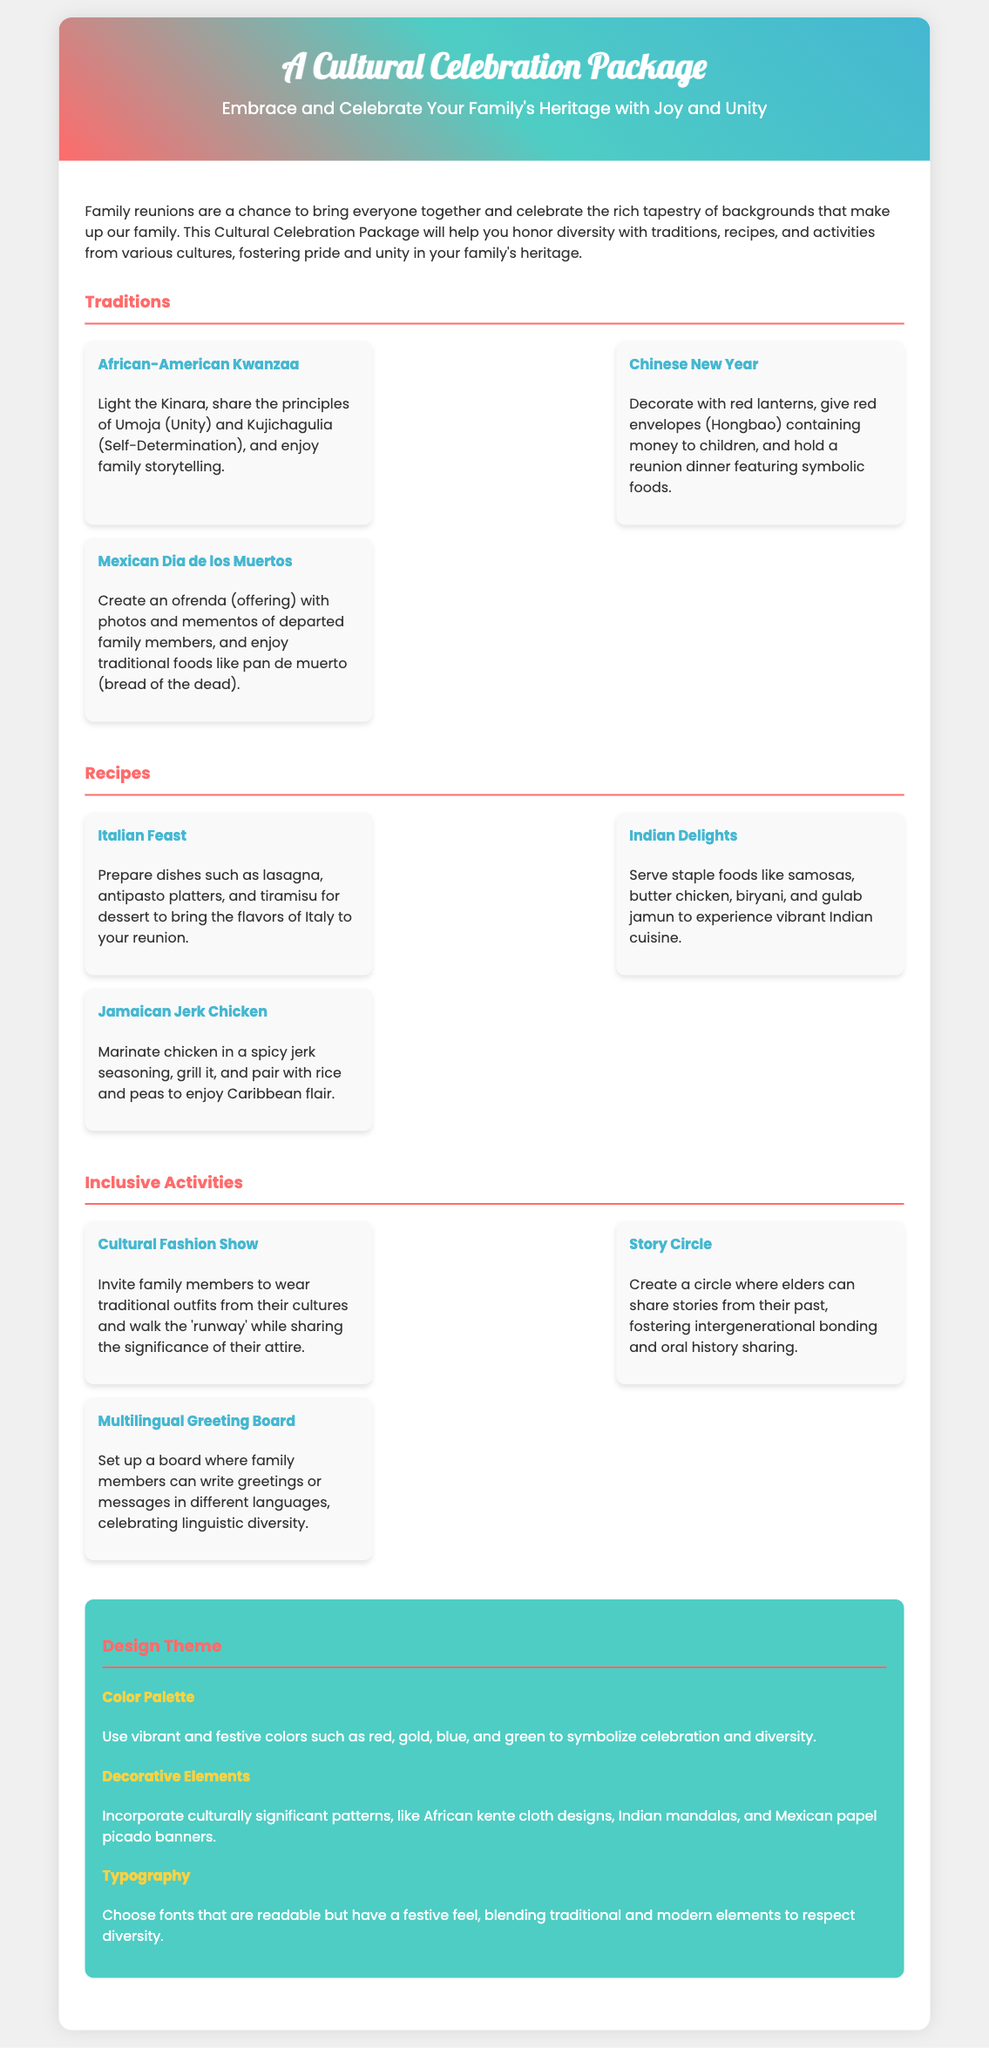What is the name of the package? The name of the package is mentioned in the header of the document.
Answer: A Cultural Celebration Package What are the three cultural traditions highlighted? The document lists three traditions under a dedicated section.
Answer: Kwanzaa, Chinese New Year, Dia de los Muertos Which dish represents Italian cuisine in the recipes section? The Italian dish is specified among the recipes provided.
Answer: Lasagna What type of activity involves sharing stories in a circle? The document details an activity where elders share their stories, specifying its type.
Answer: Story Circle What colors are suggested for the design theme? The design theme section lists a color palette, highlighting vibrant and festive colors.
Answer: Red, gold, blue, and green How many recipes are provided in the document? The number of recipes can be counted from the recipes section in the content.
Answer: Three What is the purpose of the Multilingual Greeting Board? The explanation of this activity specifies its aim in celebrating diversity.
Answer: Celebrating linguistic diversity What is the key feeling that the package aims to foster within families? The document expresses a core intention focused on family events and bonds.
Answer: Pride and unity 